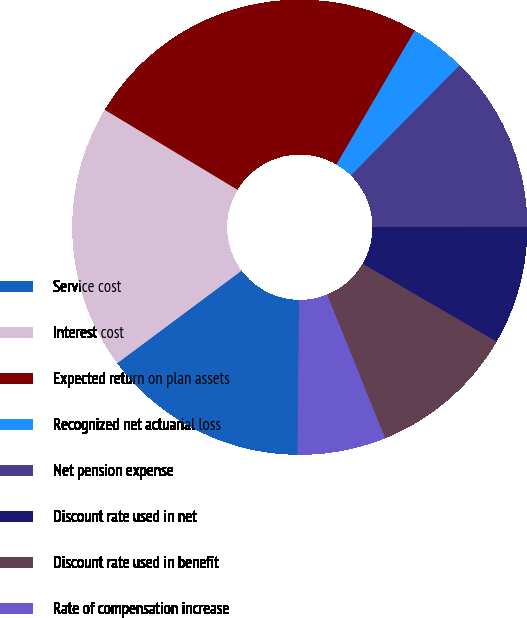Convert chart to OTSL. <chart><loc_0><loc_0><loc_500><loc_500><pie_chart><fcel>Service cost<fcel>Interest cost<fcel>Expected return on plan assets<fcel>Recognized net actuarial loss<fcel>Net pension expense<fcel>Discount rate used in net<fcel>Discount rate used in benefit<fcel>Rate of compensation increase<nl><fcel>14.66%<fcel>18.82%<fcel>24.79%<fcel>3.98%<fcel>12.58%<fcel>8.41%<fcel>10.5%<fcel>6.27%<nl></chart> 